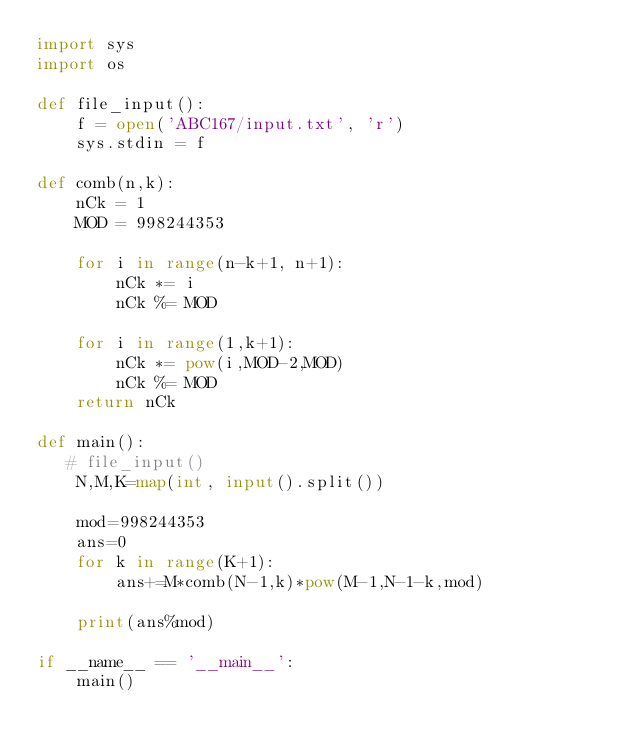Convert code to text. <code><loc_0><loc_0><loc_500><loc_500><_Python_>import sys
import os

def file_input():
    f = open('ABC167/input.txt', 'r')
    sys.stdin = f

def comb(n,k):
    nCk = 1
    MOD = 998244353

    for i in range(n-k+1, n+1):
        nCk *= i
        nCk %= MOD

    for i in range(1,k+1):
        nCk *= pow(i,MOD-2,MOD)
        nCk %= MOD
    return nCk

def main():
   # file_input()
    N,M,K=map(int, input().split())

    mod=998244353
    ans=0
    for k in range(K+1):
        ans+=M*comb(N-1,k)*pow(M-1,N-1-k,mod)

    print(ans%mod)

if __name__ == '__main__':
    main()
</code> 